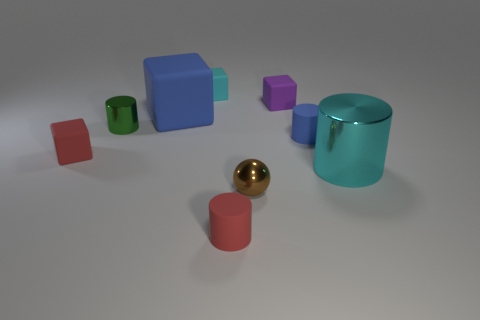Subtract all gray cylinders. Subtract all purple balls. How many cylinders are left? 4 Add 1 green matte balls. How many objects exist? 10 Add 5 cylinders. How many cylinders exist? 9 Subtract 1 blue cylinders. How many objects are left? 8 Subtract all balls. How many objects are left? 8 Subtract all big cyan objects. Subtract all small green shiny cylinders. How many objects are left? 7 Add 2 blue cubes. How many blue cubes are left? 3 